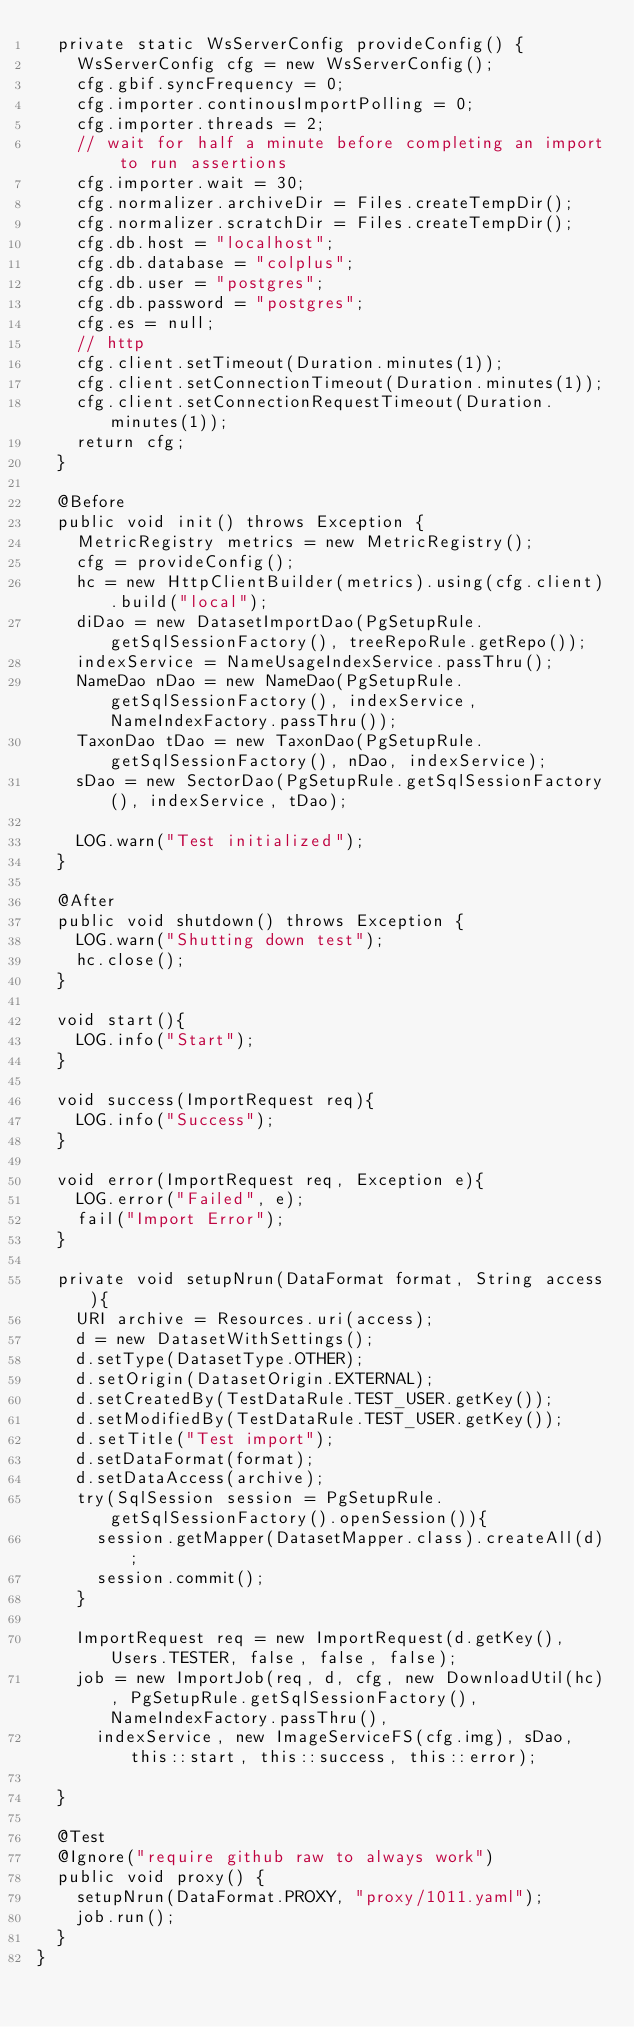<code> <loc_0><loc_0><loc_500><loc_500><_Java_>  private static WsServerConfig provideConfig() {
    WsServerConfig cfg = new WsServerConfig();
    cfg.gbif.syncFrequency = 0;
    cfg.importer.continousImportPolling = 0;
    cfg.importer.threads = 2;
    // wait for half a minute before completing an import to run assertions
    cfg.importer.wait = 30;
    cfg.normalizer.archiveDir = Files.createTempDir();
    cfg.normalizer.scratchDir = Files.createTempDir();
    cfg.db.host = "localhost";
    cfg.db.database = "colplus";
    cfg.db.user = "postgres";
    cfg.db.password = "postgres";
    cfg.es = null;
    // http
    cfg.client.setTimeout(Duration.minutes(1));
    cfg.client.setConnectionTimeout(Duration.minutes(1));
    cfg.client.setConnectionRequestTimeout(Duration.minutes(1));
    return cfg;
  }

  @Before
  public void init() throws Exception {
    MetricRegistry metrics = new MetricRegistry();
    cfg = provideConfig();
    hc = new HttpClientBuilder(metrics).using(cfg.client).build("local");
    diDao = new DatasetImportDao(PgSetupRule.getSqlSessionFactory(), treeRepoRule.getRepo());
    indexService = NameUsageIndexService.passThru();
    NameDao nDao = new NameDao(PgSetupRule.getSqlSessionFactory(), indexService, NameIndexFactory.passThru());
    TaxonDao tDao = new TaxonDao(PgSetupRule.getSqlSessionFactory(), nDao, indexService);
    sDao = new SectorDao(PgSetupRule.getSqlSessionFactory(), indexService, tDao);

    LOG.warn("Test initialized");
  }

  @After
  public void shutdown() throws Exception {
    LOG.warn("Shutting down test");
    hc.close();
  }

  void start(){
    LOG.info("Start");
  }

  void success(ImportRequest req){
    LOG.info("Success");
  }

  void error(ImportRequest req, Exception e){
    LOG.error("Failed", e);
    fail("Import Error");
  }

  private void setupNrun(DataFormat format, String access){
    URI archive = Resources.uri(access);
    d = new DatasetWithSettings();
    d.setType(DatasetType.OTHER);
    d.setOrigin(DatasetOrigin.EXTERNAL);
    d.setCreatedBy(TestDataRule.TEST_USER.getKey());
    d.setModifiedBy(TestDataRule.TEST_USER.getKey());
    d.setTitle("Test import");
    d.setDataFormat(format);
    d.setDataAccess(archive);
    try(SqlSession session = PgSetupRule.getSqlSessionFactory().openSession()){
      session.getMapper(DatasetMapper.class).createAll(d);
      session.commit();
    }

    ImportRequest req = new ImportRequest(d.getKey(), Users.TESTER, false, false, false);
    job = new ImportJob(req, d, cfg, new DownloadUtil(hc), PgSetupRule.getSqlSessionFactory(), NameIndexFactory.passThru(),
      indexService, new ImageServiceFS(cfg.img), sDao, this::start, this::success, this::error);

  }

  @Test
  @Ignore("require github raw to always work")
  public void proxy() {
    setupNrun(DataFormat.PROXY, "proxy/1011.yaml");
    job.run();
  }
}</code> 